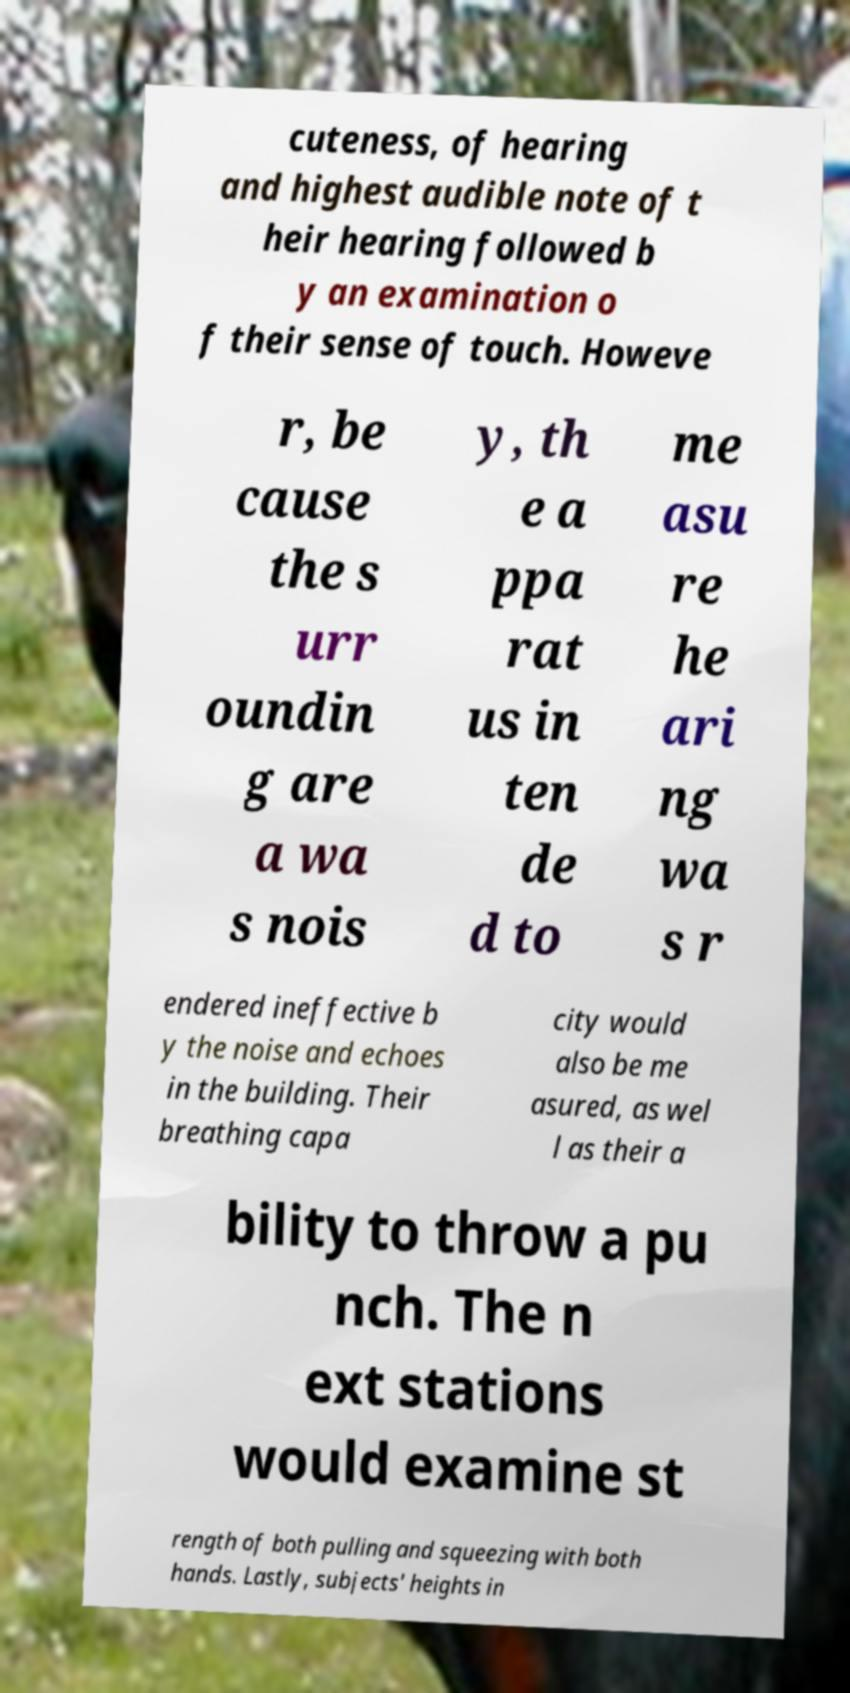What messages or text are displayed in this image? I need them in a readable, typed format. cuteness, of hearing and highest audible note of t heir hearing followed b y an examination o f their sense of touch. Howeve r, be cause the s urr oundin g are a wa s nois y, th e a ppa rat us in ten de d to me asu re he ari ng wa s r endered ineffective b y the noise and echoes in the building. Their breathing capa city would also be me asured, as wel l as their a bility to throw a pu nch. The n ext stations would examine st rength of both pulling and squeezing with both hands. Lastly, subjects' heights in 